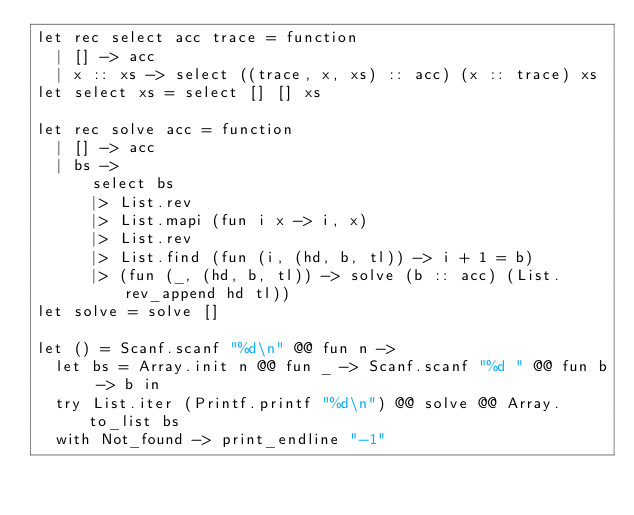<code> <loc_0><loc_0><loc_500><loc_500><_OCaml_>let rec select acc trace = function
  | [] -> acc
  | x :: xs -> select ((trace, x, xs) :: acc) (x :: trace) xs
let select xs = select [] [] xs

let rec solve acc = function
  | [] -> acc
  | bs ->
      select bs
      |> List.rev
      |> List.mapi (fun i x -> i, x)
      |> List.rev
      |> List.find (fun (i, (hd, b, tl)) -> i + 1 = b)
      |> (fun (_, (hd, b, tl)) -> solve (b :: acc) (List.rev_append hd tl))
let solve = solve []

let () = Scanf.scanf "%d\n" @@ fun n ->
  let bs = Array.init n @@ fun _ -> Scanf.scanf "%d " @@ fun b -> b in
  try List.iter (Printf.printf "%d\n") @@ solve @@ Array.to_list bs
  with Not_found -> print_endline "-1"

</code> 